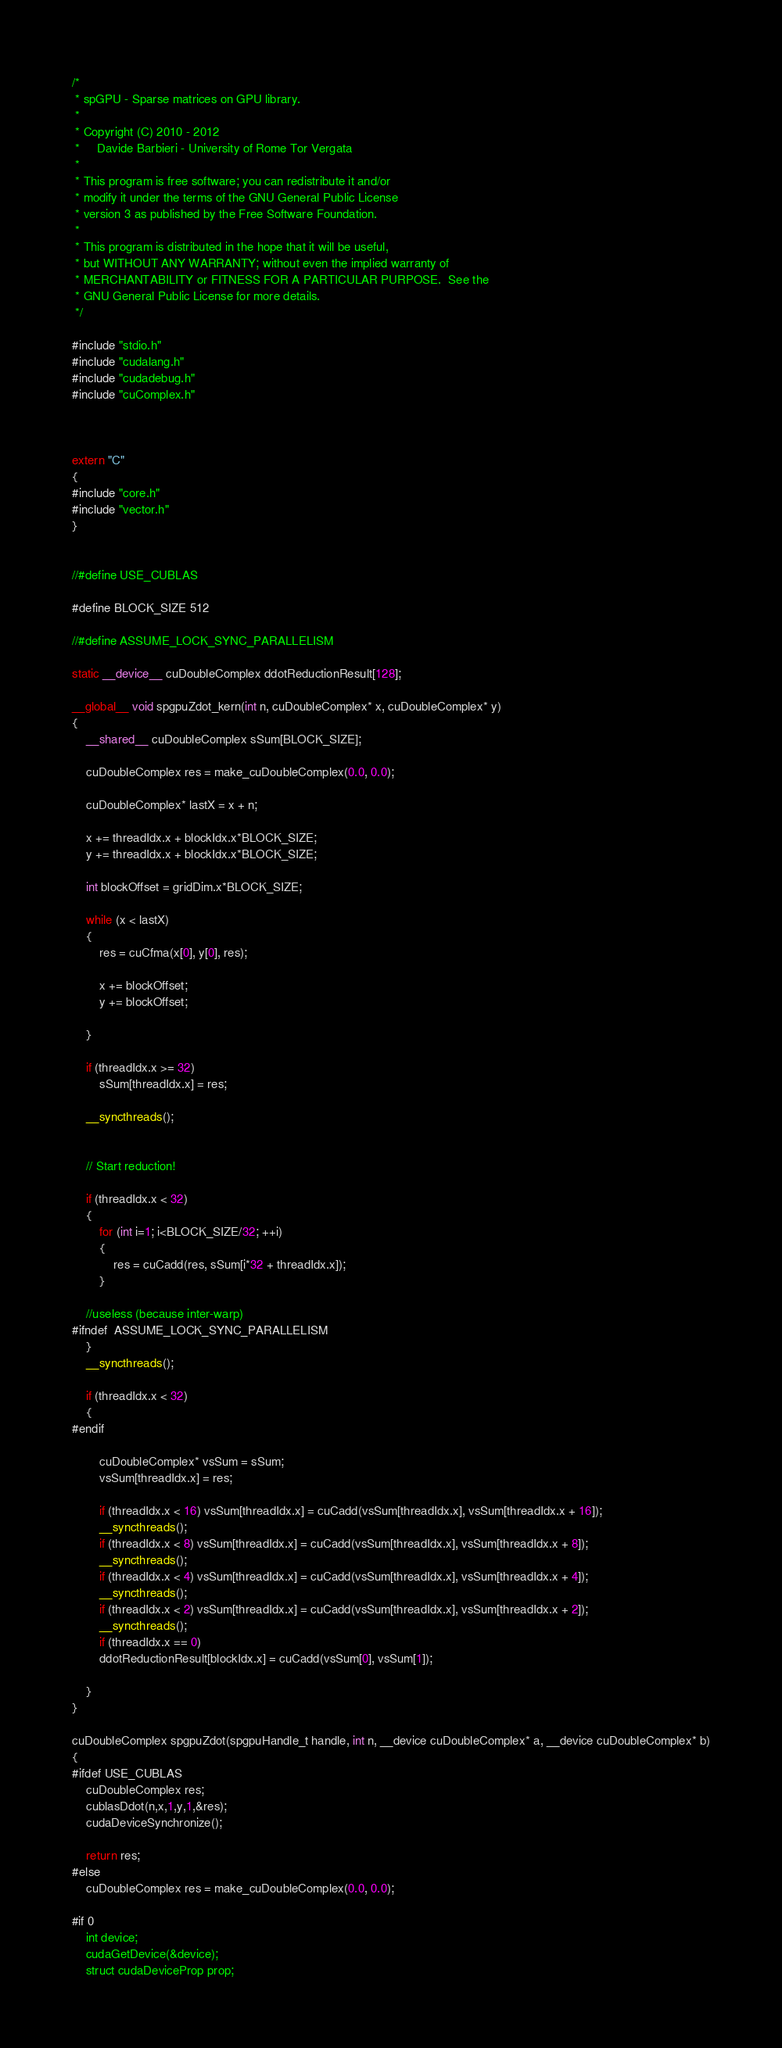<code> <loc_0><loc_0><loc_500><loc_500><_Cuda_>/*
 * spGPU - Sparse matrices on GPU library.
 * 
 * Copyright (C) 2010 - 2012 
 *     Davide Barbieri - University of Rome Tor Vergata
 *
 * This program is free software; you can redistribute it and/or
 * modify it under the terms of the GNU General Public License
 * version 3 as published by the Free Software Foundation.
 *
 * This program is distributed in the hope that it will be useful,
 * but WITHOUT ANY WARRANTY; without even the implied warranty of
 * MERCHANTABILITY or FITNESS FOR A PARTICULAR PURPOSE.  See the
 * GNU General Public License for more details.
 */

#include "stdio.h"
#include "cudalang.h"
#include "cudadebug.h"
#include "cuComplex.h"



extern "C"
{
#include "core.h"
#include "vector.h"
}


//#define USE_CUBLAS

#define BLOCK_SIZE 512

//#define ASSUME_LOCK_SYNC_PARALLELISM

static __device__ cuDoubleComplex ddotReductionResult[128];

__global__ void spgpuZdot_kern(int n, cuDoubleComplex* x, cuDoubleComplex* y)
{
	__shared__ cuDoubleComplex sSum[BLOCK_SIZE];

	cuDoubleComplex res = make_cuDoubleComplex(0.0, 0.0);

	cuDoubleComplex* lastX = x + n;

	x += threadIdx.x + blockIdx.x*BLOCK_SIZE;
	y += threadIdx.x + blockIdx.x*BLOCK_SIZE;

	int blockOffset = gridDim.x*BLOCK_SIZE;

	while (x < lastX)
    {
		res = cuCfma(x[0], y[0], res);
		
		x += blockOffset;
		y += blockOffset;

	}

	if (threadIdx.x >= 32)
		sSum[threadIdx.x] = res;

	__syncthreads();


	// Start reduction!

	if (threadIdx.x < 32) 
	{
		for (int i=1; i<BLOCK_SIZE/32; ++i)
		{
			res = cuCadd(res, sSum[i*32 + threadIdx.x]);
		}

	//useless (because inter-warp)
#ifndef	ASSUME_LOCK_SYNC_PARALLELISM
	}
	__syncthreads(); 

	if (threadIdx.x < 32) 
	{
#endif	

		cuDoubleComplex* vsSum = sSum;
		vsSum[threadIdx.x] = res;

		if (threadIdx.x < 16) vsSum[threadIdx.x] = cuCadd(vsSum[threadIdx.x], vsSum[threadIdx.x + 16]);
		__syncthreads();
		if (threadIdx.x < 8) vsSum[threadIdx.x] = cuCadd(vsSum[threadIdx.x], vsSum[threadIdx.x + 8]);
		__syncthreads();
		if (threadIdx.x < 4) vsSum[threadIdx.x] = cuCadd(vsSum[threadIdx.x], vsSum[threadIdx.x + 4]);
		__syncthreads();
		if (threadIdx.x < 2) vsSum[threadIdx.x] = cuCadd(vsSum[threadIdx.x], vsSum[threadIdx.x + 2]);
		__syncthreads();
		if (threadIdx.x == 0)
		ddotReductionResult[blockIdx.x] = cuCadd(vsSum[0], vsSum[1]);

	}
}

cuDoubleComplex spgpuZdot(spgpuHandle_t handle, int n, __device cuDoubleComplex* a, __device cuDoubleComplex* b)
{
#ifdef USE_CUBLAS
	cuDoubleComplex res;
	cublasDdot(n,x,1,y,1,&res);
	cudaDeviceSynchronize();
	
	return res;
#else
	cuDoubleComplex res = make_cuDoubleComplex(0.0, 0.0);

#if 0 	
	int device;
	cudaGetDevice(&device);
	struct cudaDeviceProp prop;</code> 